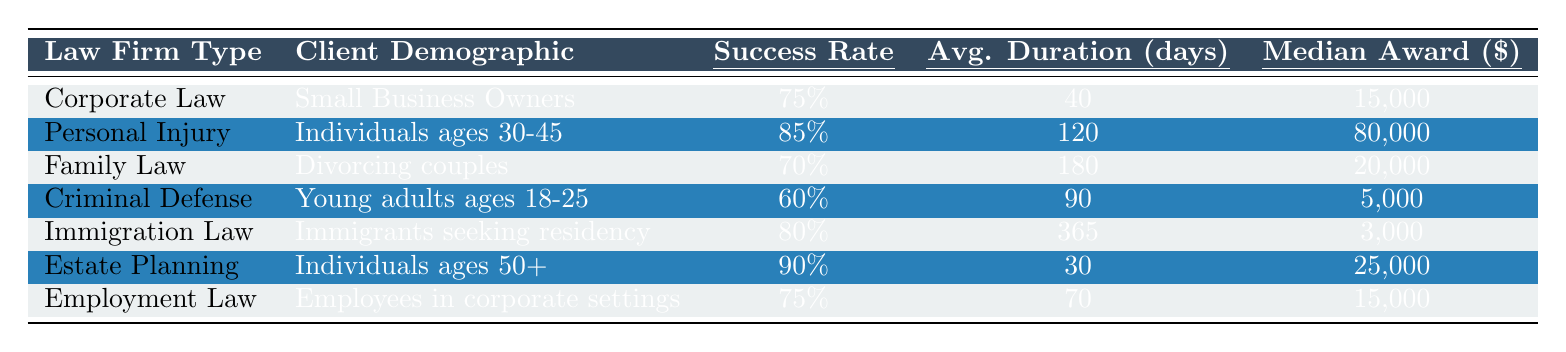What is the case success rate for Personal Injury Law Firms? The table shows that the success rate for Personal Injury Law Firms is listed under the "Success Rate" column for this law firm type, which is 85%.
Answer: 85% What is the median award amount for clients of Family Law Firms? The median award amount for Family Law Firms is indicated in the "Median Award" column corresponding to Family Law, which is $20,000.
Answer: $20,000 Which law firm type has the lowest case success rate? By examining the "Success Rate" column, Criminal Defense Law Firms have the lowest success rate at 60%.
Answer: Criminal Defense Law Firm What is the average duration of cases for Immigration Law Firms? The average duration of cases is found in the "Avg. Duration (days)" column for Immigration Law Firms, which shows an average duration of 365 days.
Answer: 365 days Is the median award amount for Estate Planning Law Firms greater than $20,000? The median award amount for Estate Planning Law Firms is $25,000, which is indeed greater than $20,000.
Answer: Yes What is the difference between the case success rates of Corporate Law Firms and Employment Law Firms? The success rate for Corporate Law Firms is 75% and for Employment Law Firms is also 75%. The difference is 75% - 75% = 0%.
Answer: 0% Which law firm type has the highest median award amount, and what is that amount? By reviewing the "Median Award" column, Personal Injury Law Firms have the highest median award amount of $80,000.
Answer: Personal Injury Law Firm, $80,000 If a client is a Small Business Owner, how many fewer days on average will their case last compared to a client of Family Law Firms? For Corporate Law Firms serving Small Business Owners, cases last an average of 40 days, while Family Law Firms have an average of 180 days. The difference is 180 - 40 = 140 days.
Answer: 140 days What is the overall average case success rate for all law firm types listed? The case success rates are 75%, 85%, 70%, 60%, 80%, 90%, and 75%. To find the average, sum them up (75 + 85 + 70 + 60 + 80 + 90 + 75) = 535 and divide by the number of law firms (7), resulting in an overall average success rate of 535/7 = 76.43%.
Answer: 76.43% Do most families seeking legal assistance have a case success rate of over 70%? From the data, Family Law Firms have a success rate of 70%, which is not over 70%. Therefore, most families do not have a case success rate over 70%.
Answer: No 